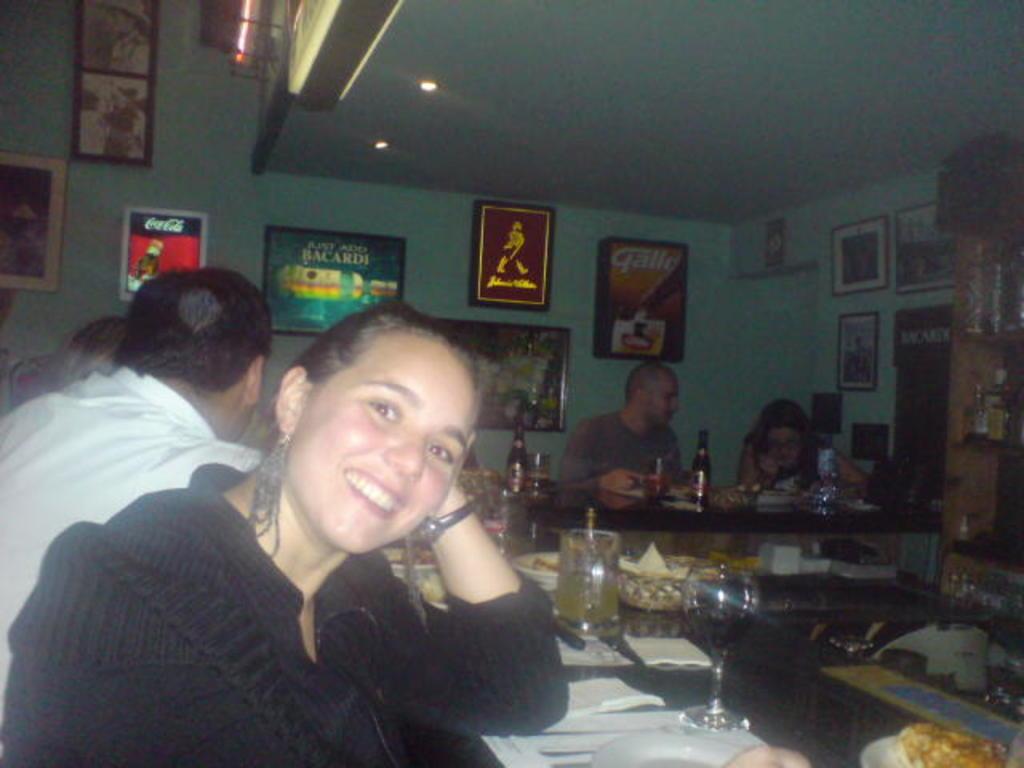Describe this image in one or two sentences. In this image, there are three persons sitting in the left side of the image. Two persons are sitting in the middle of the image. In the center, there is a table on which napkins, glasses, bottles, plates and food is kept. The roof top is blue in color. In the left side of the image and both sides wall paintings are visible. On the top left of the image, window is visible on which curtain is there. The picture is taken inside the house. 